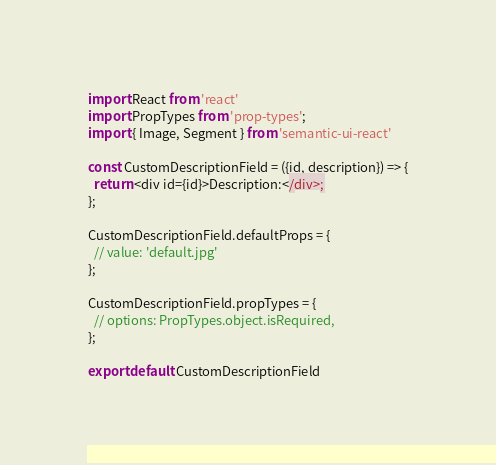Convert code to text. <code><loc_0><loc_0><loc_500><loc_500><_JavaScript_>import React from 'react'
import PropTypes from 'prop-types';
import { Image, Segment } from 'semantic-ui-react'

const CustomDescriptionField = ({id, description}) => {
  return <div id={id}>Description:</div>;
};

CustomDescriptionField.defaultProps = {
  // value: 'default.jpg'
};

CustomDescriptionField.propTypes = {
  // options: PropTypes.object.isRequired,
};

export default CustomDescriptionField
</code> 